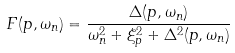<formula> <loc_0><loc_0><loc_500><loc_500>F ( { p } , \omega _ { n } ) = \frac { \Delta ( { p } , \omega _ { n } ) } { \omega _ { n } ^ { 2 } + \xi _ { p } ^ { 2 } + \Delta ^ { 2 } ( { p } , \omega _ { n } ) }</formula> 